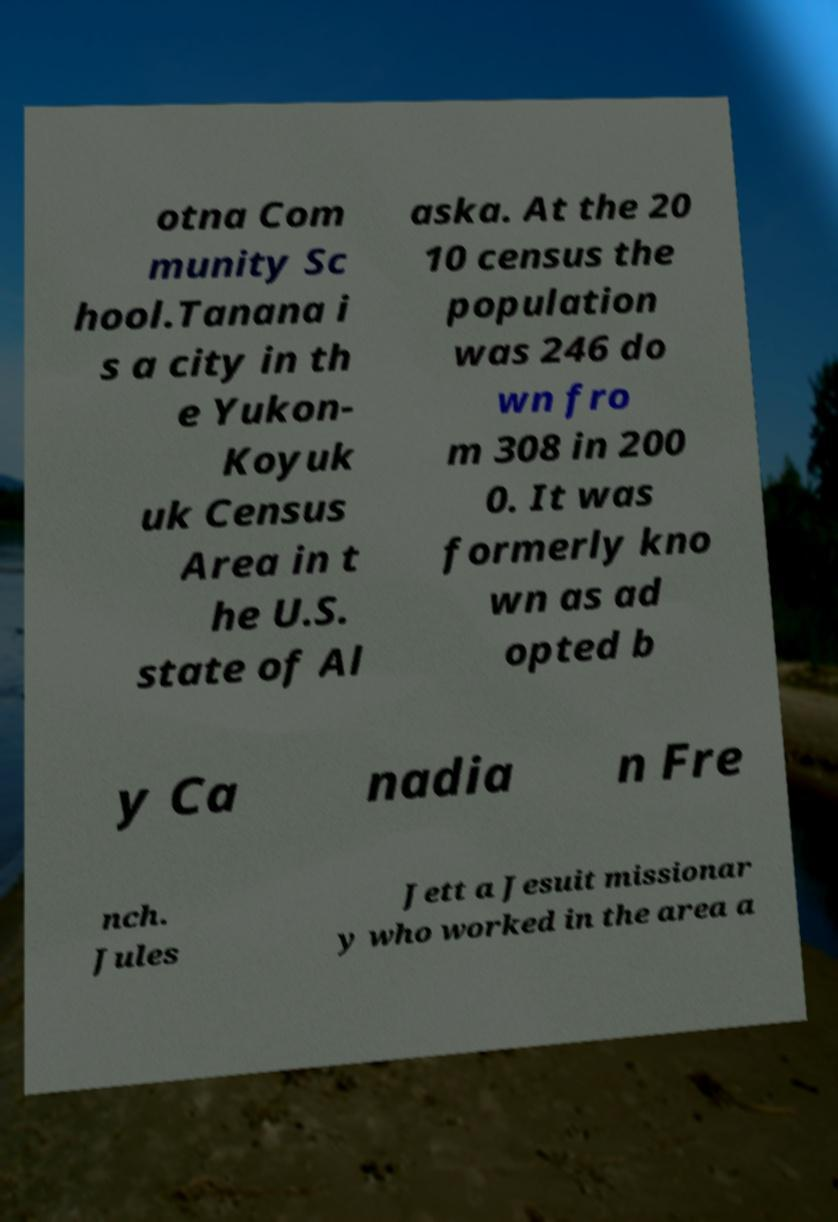Can you accurately transcribe the text from the provided image for me? otna Com munity Sc hool.Tanana i s a city in th e Yukon- Koyuk uk Census Area in t he U.S. state of Al aska. At the 20 10 census the population was 246 do wn fro m 308 in 200 0. It was formerly kno wn as ad opted b y Ca nadia n Fre nch. Jules Jett a Jesuit missionar y who worked in the area a 